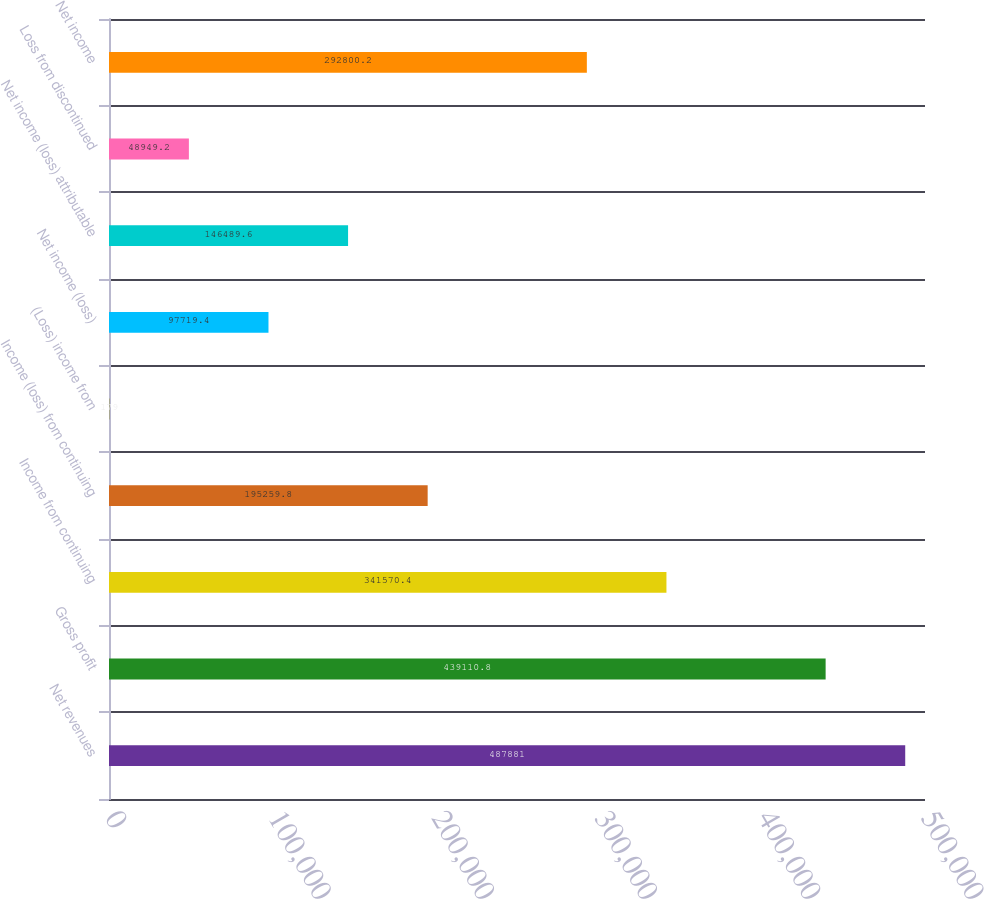Convert chart. <chart><loc_0><loc_0><loc_500><loc_500><bar_chart><fcel>Net revenues<fcel>Gross profit<fcel>Income from continuing<fcel>Income (loss) from continuing<fcel>(Loss) income from<fcel>Net income (loss)<fcel>Net income (loss) attributable<fcel>Loss from discontinued<fcel>Net income<nl><fcel>487881<fcel>439111<fcel>341570<fcel>195260<fcel>179<fcel>97719.4<fcel>146490<fcel>48949.2<fcel>292800<nl></chart> 